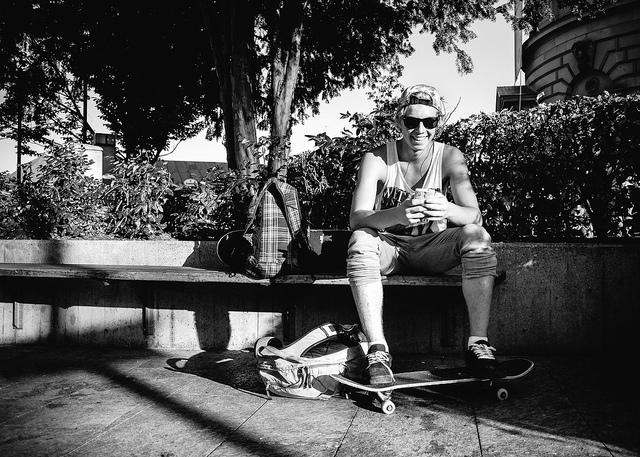Is the boys arms pointed in the same direction?
Answer briefly. Yes. Are there any old people in this picture?
Write a very short answer. No. What is the man in plaid looking at?
Be succinct. Camera. On what surface is the guy sitting?
Keep it brief. Bench. What is the guys feet on?
Keep it brief. Skateboard. What year was this taken?
Concise answer only. 2012. How many people are sitting down?
Answer briefly. 1. 